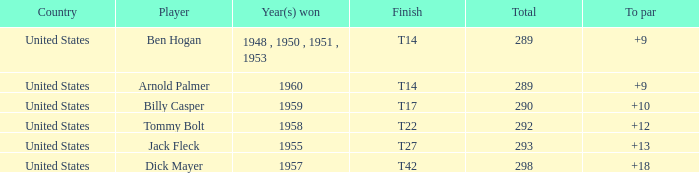What is Country, when Total is less than 290, and when Year(s) Won is 1960? United States. Would you mind parsing the complete table? {'header': ['Country', 'Player', 'Year(s) won', 'Finish', 'Total', 'To par'], 'rows': [['United States', 'Ben Hogan', '1948 , 1950 , 1951 , 1953', 'T14', '289', '+9'], ['United States', 'Arnold Palmer', '1960', 'T14', '289', '+9'], ['United States', 'Billy Casper', '1959', 'T17', '290', '+10'], ['United States', 'Tommy Bolt', '1958', 'T22', '292', '+12'], ['United States', 'Jack Fleck', '1955', 'T27', '293', '+13'], ['United States', 'Dick Mayer', '1957', 'T42', '298', '+18']]} 